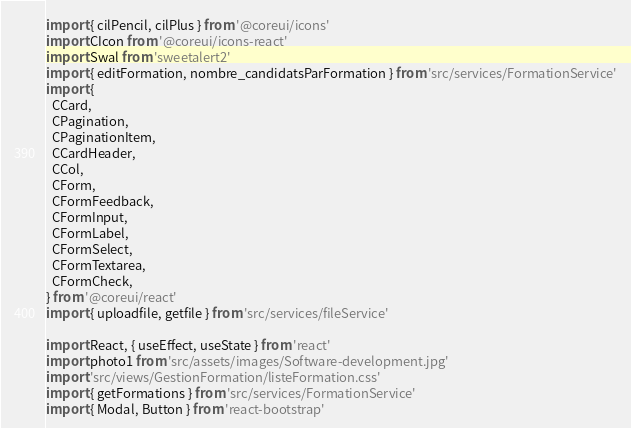Convert code to text. <code><loc_0><loc_0><loc_500><loc_500><_JavaScript_>import { cilPencil, cilPlus } from '@coreui/icons'
import CIcon from '@coreui/icons-react'
import Swal from 'sweetalert2'
import { editFormation, nombre_candidatsParFormation } from 'src/services/FormationService'
import {
  CCard,
  CPagination,
  CPaginationItem,
  CCardHeader,
  CCol,
  CForm,
  CFormFeedback,
  CFormInput,
  CFormLabel,
  CFormSelect,
  CFormTextarea,
  CFormCheck,
} from '@coreui/react'
import { uploadfile, getfile } from 'src/services/fileService'

import React, { useEffect, useState } from 'react'
import photo1 from 'src/assets/images/Software-development.jpg'
import 'src/views/GestionFormation/listeFormation.css'
import { getFormations } from 'src/services/FormationService'
import { Modal, Button } from 'react-bootstrap'</code> 